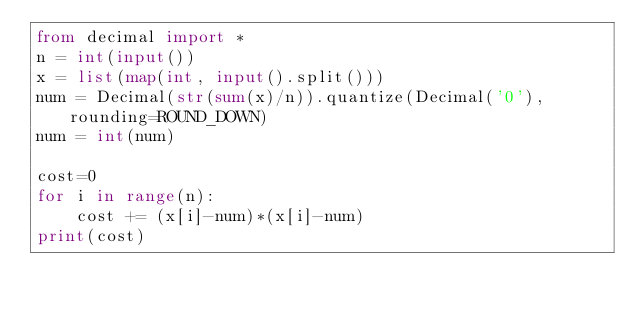Convert code to text. <code><loc_0><loc_0><loc_500><loc_500><_Python_>from decimal import *
n = int(input())
x = list(map(int, input().split()))
num = Decimal(str(sum(x)/n)).quantize(Decimal('0'), rounding=ROUND_DOWN)
num = int(num)

cost=0
for i in range(n):
    cost += (x[i]-num)*(x[i]-num)
print(cost)</code> 